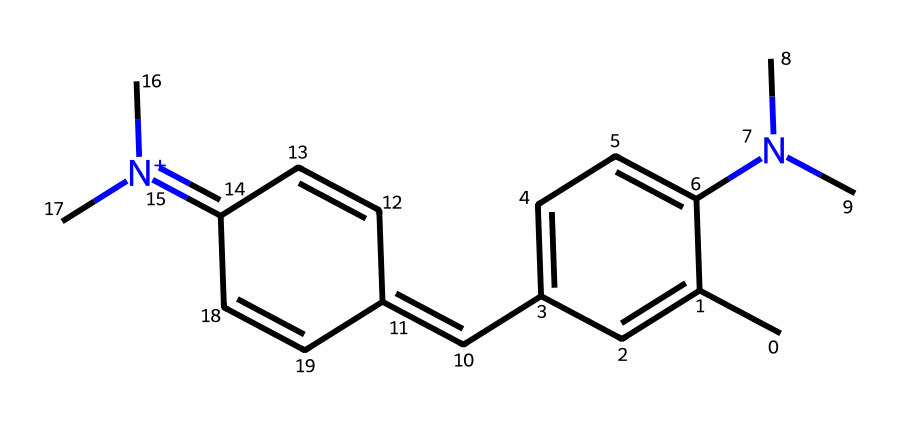What is the total number of carbon atoms in the molecule? By analyzing the SMILES representation, we can count the number of carbon (C) atoms present. Each carbon atom is denoted by 'C', and counting reveals there are 15 carbon atoms.
Answer: 15 How many nitrogen atoms are present in this structure? In the provided SMILES, the presence of nitrogen (N) is indicated by 'N'. Counting the occurrences of 'N' reveals there are 2 nitrogen atoms.
Answer: 2 What type of chemical structure is this compound classified as? This molecule is characterized by its framework, which includes conjugated double bonds and aromatic properties. Given its photoreactive nature and focus on fluorescence, it is classified as a dye or pigment.
Answer: dye Does this chemical contain a quaternary ammonium group? A quaternary ammonium group is typically indicated by a positively charged nitrogen atom connected to four carbon groups. The SMILES shows a nitrogen 'N+' with two methyl groups attached, confirming it as a quaternary ammonium.
Answer: yes What is the likely application of this compound in tattoos? The presence of a fluorescent structure, which is capable of being activated by UV light, indicates that this compound would be used in tattoos that react under blacklight, appearing brightly colored.
Answer: blacklight-reactive What indicates the presence of conjugation in this molecule? Conjugation in organic compounds occurs when alternating single and double bonds allow for electron delocalization. By observing the pattern of double bonds and the cyclic structure in the SMILES representation, we can identify regions of conjugation.
Answer: alternating double bonds How does the presence of nitrogen affect the light absorption properties of the molecule? The nitrogen atoms in the structure can influence the electronic properties of the compound, such as altering the energy levels of electrons. This can modify how the compound absorbs and emits light, typically increasing the brightness or changing the wavelength of fluorescence.
Answer: alters light absorption 